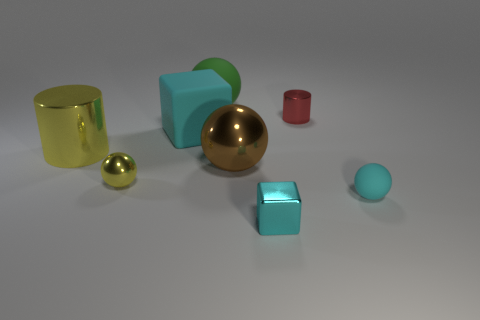What number of other green matte objects are the same size as the green object?
Provide a short and direct response. 0. What material is the yellow cylinder?
Keep it short and to the point. Metal. Are there any small cyan cubes to the left of the tiny cyan metallic cube?
Your answer should be very brief. No. There is a cyan thing that is made of the same material as the large brown thing; what is its size?
Offer a terse response. Small. What number of metal spheres are the same color as the small metal cube?
Provide a short and direct response. 0. Are there fewer small red things that are in front of the large yellow shiny cylinder than big green rubber balls that are in front of the green rubber sphere?
Your answer should be compact. No. What is the size of the thing in front of the small rubber thing?
Provide a short and direct response. Small. What size is the thing that is the same color as the big shiny cylinder?
Make the answer very short. Small. Is there a big cyan object that has the same material as the big green object?
Keep it short and to the point. Yes. Is the small red cylinder made of the same material as the tiny yellow sphere?
Provide a short and direct response. Yes. 